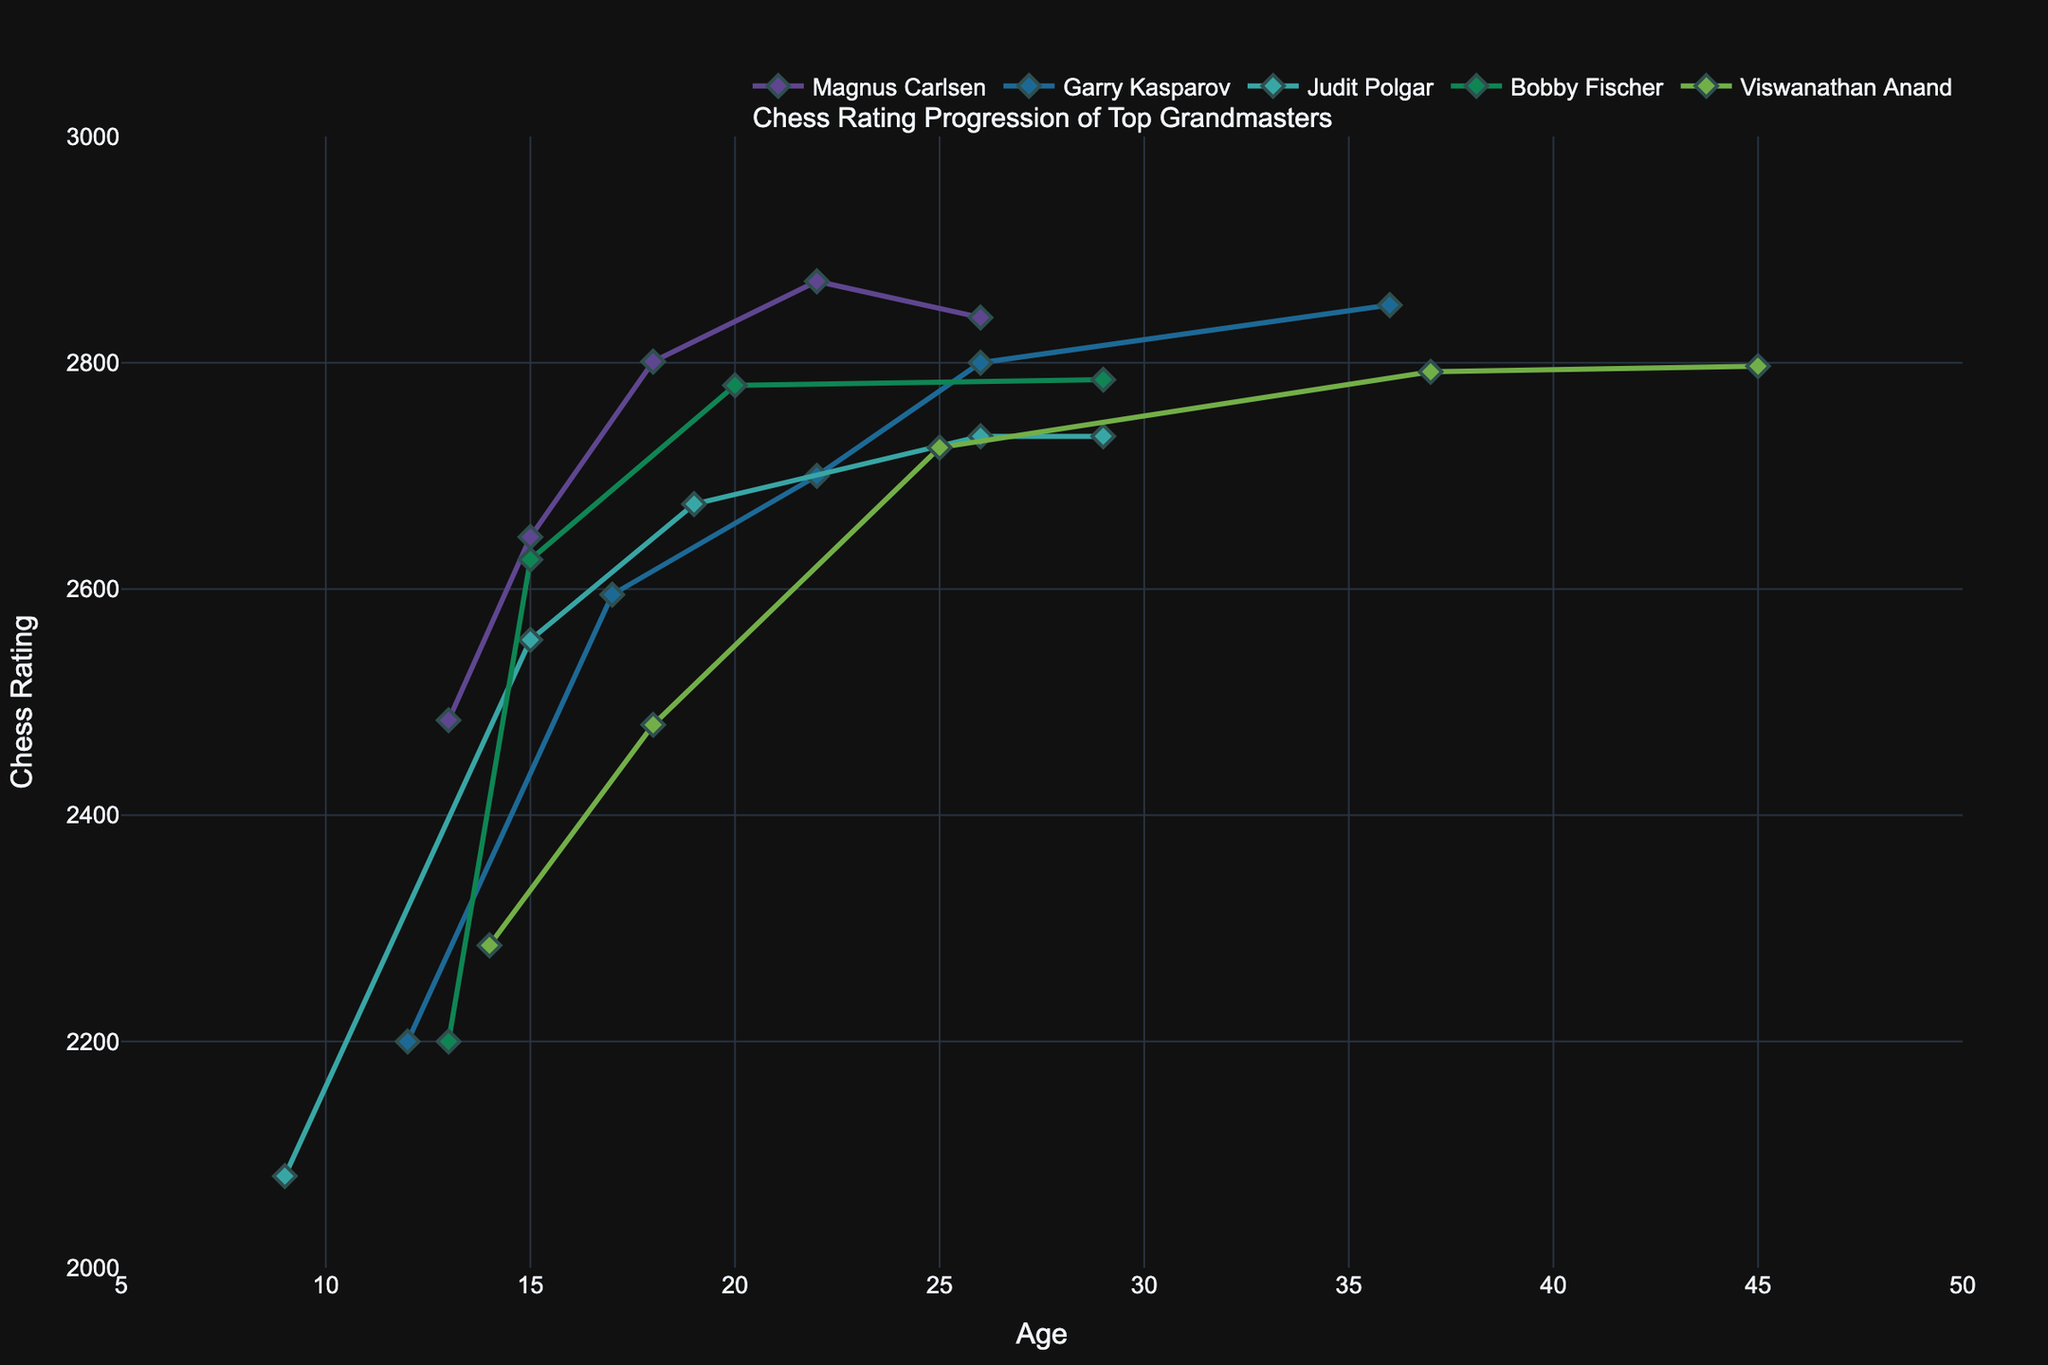Which player has the highest rating at their peak? From the plot, we observe that Garry Kasparov reaches the highest peak rating of all players, which is 2851 when he is 36 years old.
Answer: Garry Kasparov At what age did Magnus Carlsen achieve his peak rating? According to the chart, Magnus Carlsen's peak rating of 2872 is achieved at the age of 22.
Answer: 22 How does the rating progression of Judit Polgar compare with Bobby Fischer between the ages of 9 and 20? Judit Polgar starts at a lower rating of 2081 at age 9 compared to Bobby Fischer's 2200 at age 13. By age 20, Judit Polgar reaches 2675, while Bobby Fischer hits 2780. They both show a sharp increase, but Bobby Fischer has a higher rating at comparable ages.
Answer: Bobby Fischer has higher ratings at comparable ages Which player shows the most consistent increase in their rating over their career? Viswanathan Anand shows a consistent increase in his rating, starting from 2285 at age 14 to 2797 at age 45, with fewer fluctuations compared to other players.
Answer: Viswanathan Anand What is the difference in peak ratings between Garry Kasparov and Viswanathan Anand? Garry Kasparov's peak rating is 2851, and Viswanathan Anand's peak rating is 2797. The difference between these ratings is 2851 - 2797 = 54.
Answer: 54 Is there any player who has a higher rating than Magnus Carlsen at the same age? No other player has a higher rating than Magnus Carlsen at the age of 22. Magnus Carlsen's 2872 is the highest at that age among the players compared.
Answer: No How does the rating progression of Garry Kasparov between ages 12 and 26 compare with Magnus Carlsen's progression for the same age interval? Garry Kasparov starts at 2200 at age 12 and climbs to 2800 by age 26. Magnus Carlsen starts later, at age 13 with 2484, and reaches 2840 by age 26. Both show rapid increases, but Magnus Carlsen starts higher and ends slightly higher by age 26.
Answer: Both show rapid increases, but Magnus Carlsen starts and ends higher by age 26 What visual indication shows the tournament at which Judit Polgar reached the rating of 2735 for the first time? The visual indication of the tournament where Judit Polgar first reached 2735 is represented by a datapoint marked with a diamond at age 26, labeled "Russia vs The Rest of the World".
Answer: Diamond marked at age 26 What is the average peak rating of the grandmasters shown in the plot? The peak ratings are Magnus Carlsen (2872), Garry Kasparov (2851), Judit Polgar (2735), Bobby Fischer (2785), and Viswanathan Anand (2797). The average peak rating is (2872 + 2851 + 2735 + 2785 + 2797) / 5 = 2808.
Answer: 2808 